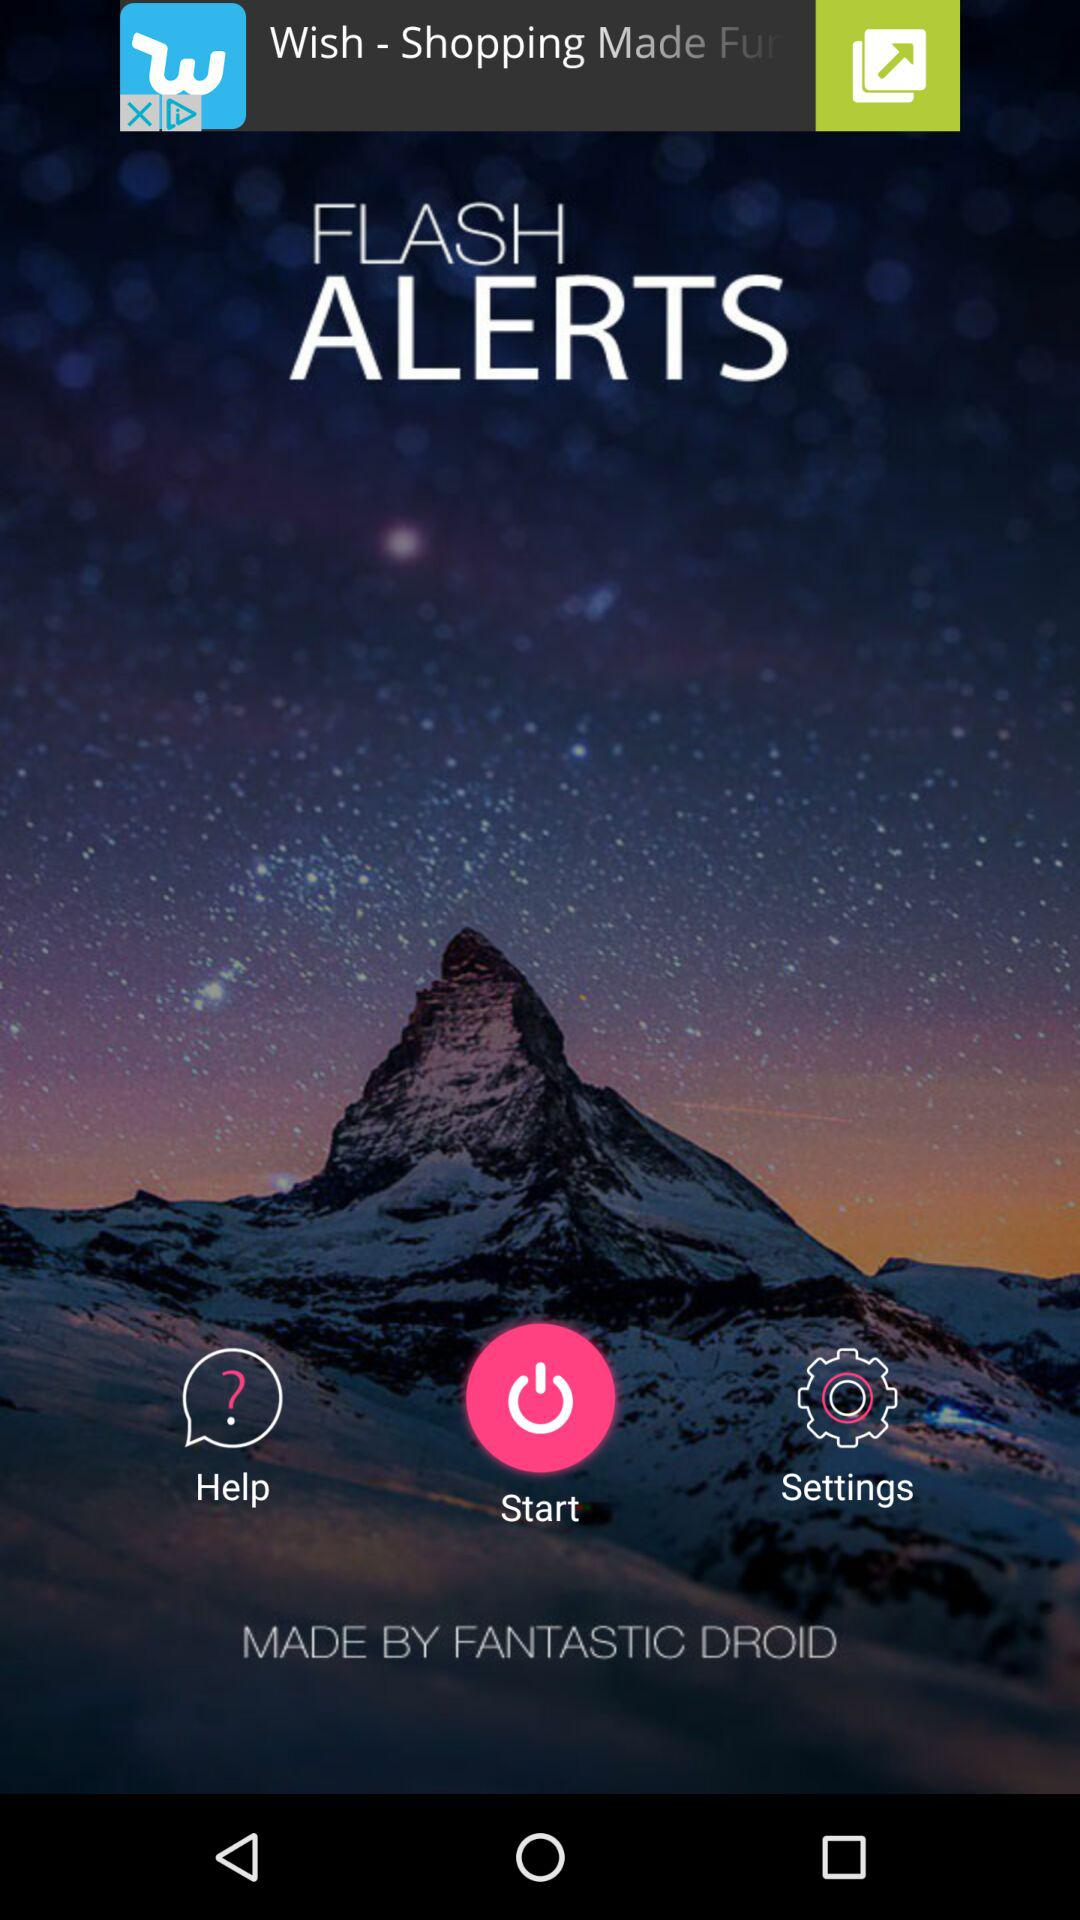What's the developer name? The developer name is Fantastic Droid. 